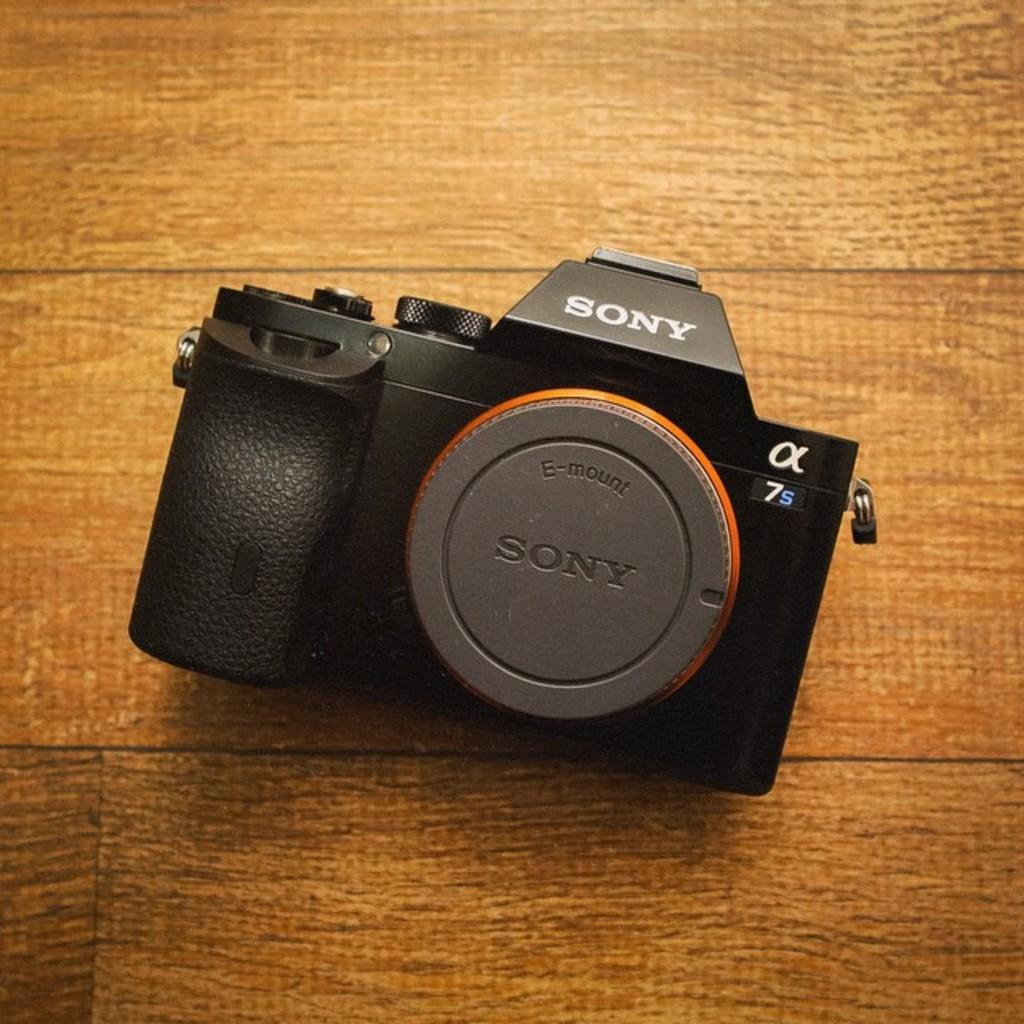<image>
Describe the image concisely. A Sony camera is resting on a wooden table. 